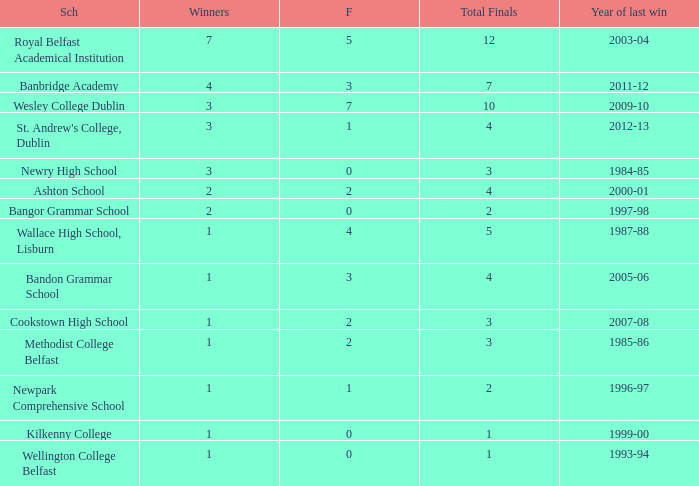In what year was the total finals at 10? 2009-10. 